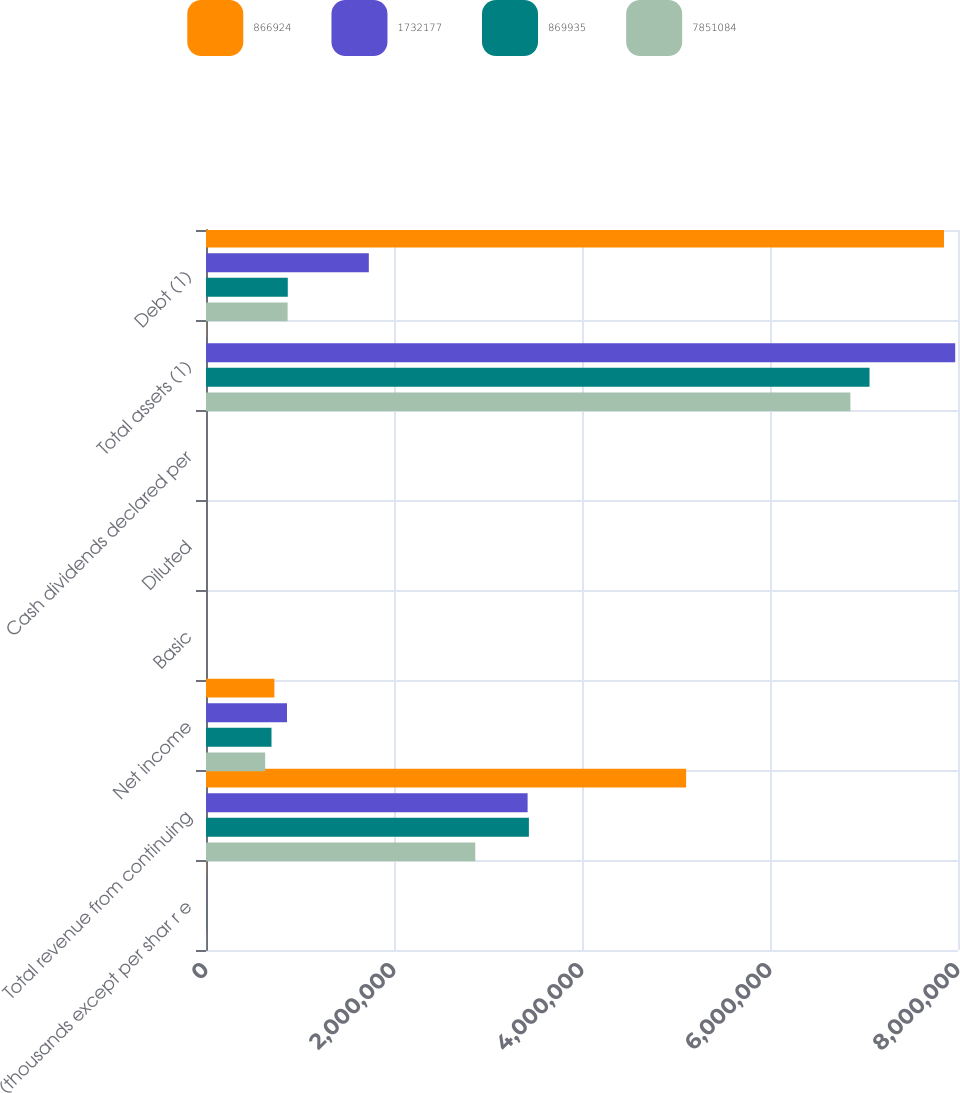Convert chart to OTSL. <chart><loc_0><loc_0><loc_500><loc_500><stacked_bar_chart><ecel><fcel>(thousands except per shar r e<fcel>Total revenue from continuing<fcel>Net income<fcel>Basic<fcel>Diluted<fcel>Cash dividends declared per<fcel>Total assets (1)<fcel>Debt (1)<nl><fcel>866924<fcel>2017<fcel>5.1075e+06<fcel>727259<fcel>2.09<fcel>2.07<fcel>1.77<fcel>2017<fcel>7.85108e+06<nl><fcel>1.73218e+06<fcel>2016<fcel>3.42141e+06<fcel>861664<fcel>2.79<fcel>2.76<fcel>1.66<fcel>7.97028e+06<fcel>1.73218e+06<nl><fcel>869935<fcel>2015<fcel>3.43509e+06<fcel>696878<fcel>2.23<fcel>2.2<fcel>1.57<fcel>7.05878e+06<fcel>869935<nl><fcel>7.85108e+06<fcel>2014<fcel>2.86477e+06<fcel>629320<fcel>2.01<fcel>1.98<fcel>1.45<fcel>6.85533e+06<fcel>868430<nl></chart> 